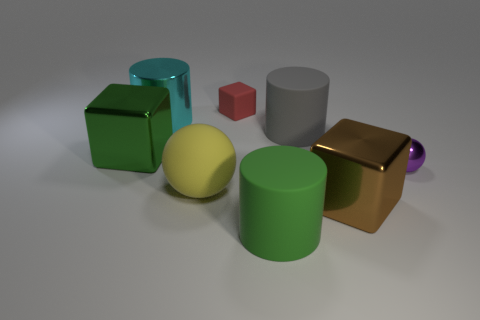How many big gray things are made of the same material as the green cylinder?
Your answer should be compact. 1. There is a green shiny cube; does it have the same size as the rubber thing that is behind the large gray cylinder?
Offer a terse response. No. There is a matte thing that is on the left side of the large green matte object and behind the big yellow rubber ball; what color is it?
Ensure brevity in your answer.  Red. Is there a big metal cube behind the large metallic object that is to the right of the large yellow object?
Your answer should be compact. Yes. Is the number of rubber things in front of the brown metal cube the same as the number of red rubber things?
Provide a succinct answer. Yes. What number of things are to the right of the large metallic block left of the rubber cylinder behind the yellow matte thing?
Offer a terse response. 7. Is there a cyan metallic cylinder of the same size as the red rubber object?
Give a very brief answer. No. Are there fewer matte cubes behind the purple shiny ball than large green rubber cylinders?
Offer a very short reply. No. What material is the cylinder in front of the big metallic cube behind the ball that is on the left side of the matte block?
Your answer should be compact. Rubber. Is the number of tiny balls that are behind the big brown metal block greater than the number of things right of the large green cylinder?
Make the answer very short. No. 